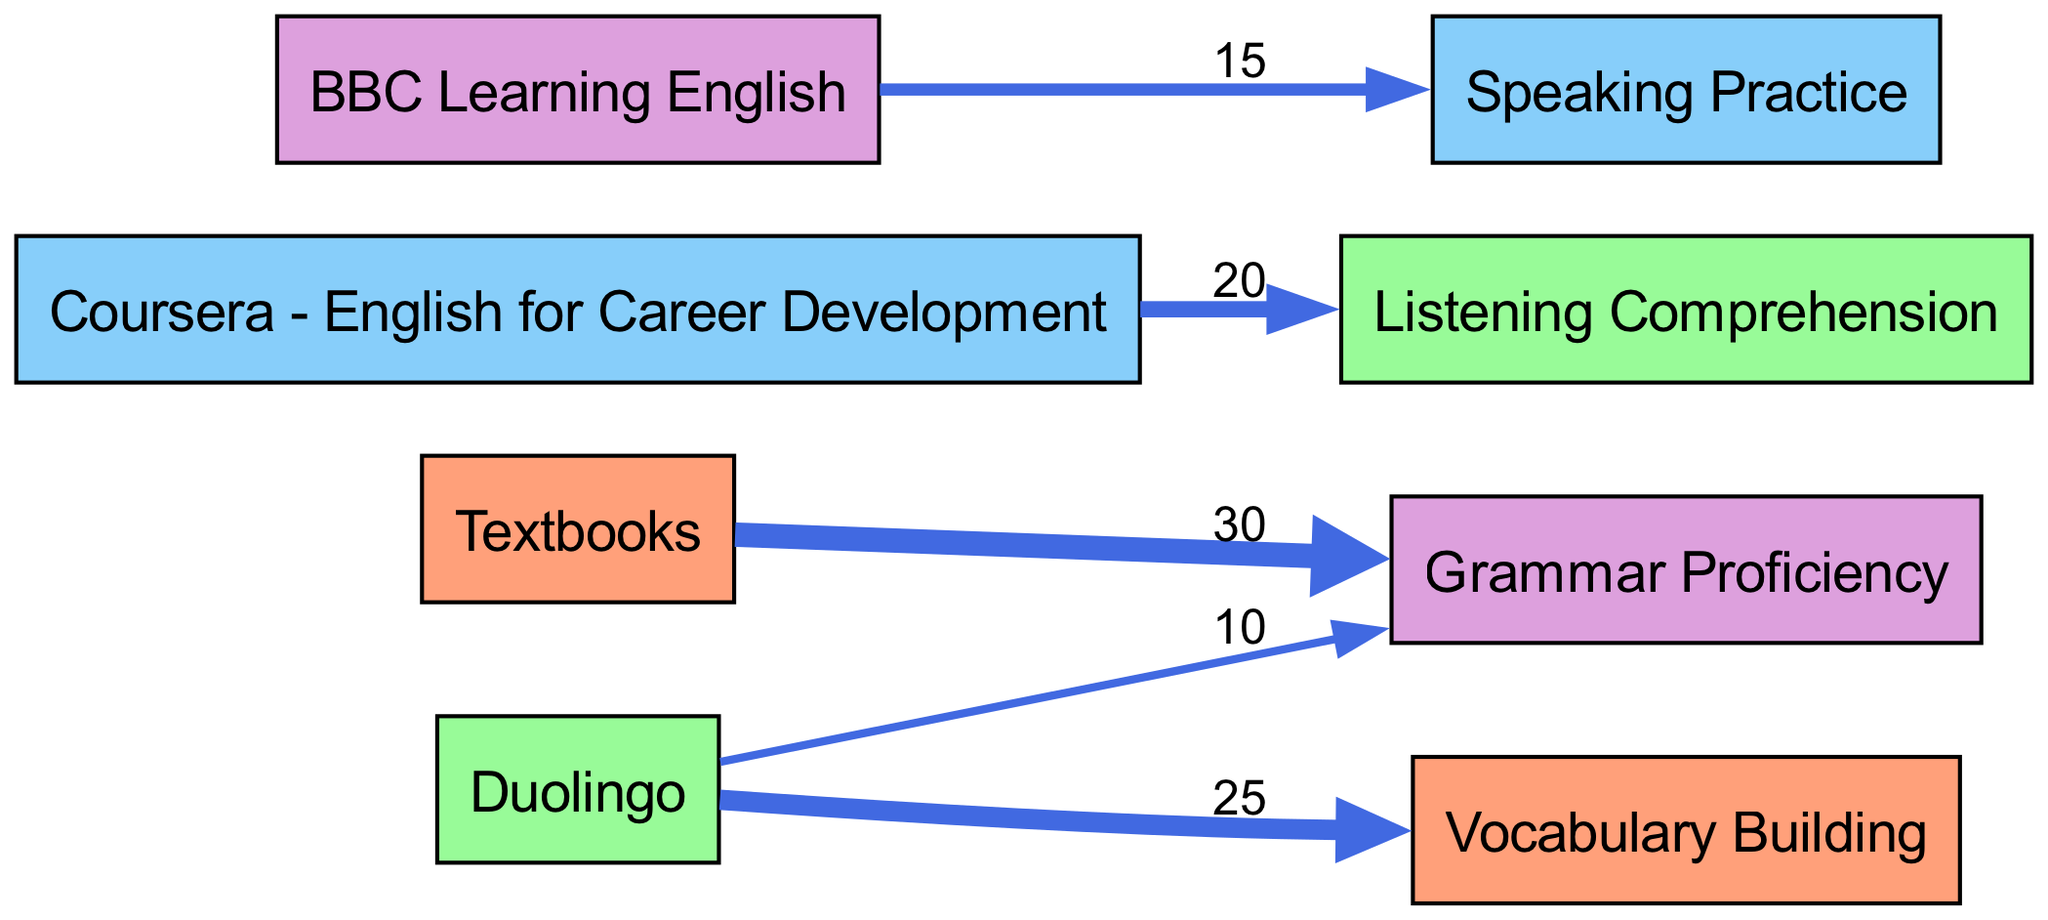What is the value indicating connection between Textbooks and Grammar Proficiency? The connection between Textbooks and Grammar Proficiency shows the value of 30, which is indicated directly on the edge connecting these two nodes in the diagram.
Answer: 30 Which learning resource has the highest connection value? By comparing the connection values of all resources, Textbooks has the highest connection value of 30 to Grammar Proficiency, making it the resource with the most significant impact.
Answer: Textbooks How many total distinct learning goals are represented in the diagram? There are four distinct learning goals represented: Vocabulary Building, Listening Comprehension, Speaking Practice, and Grammar Proficiency, each connected to different resources.
Answer: Four Which app is associated with Vocabulary Building? The app associated with Vocabulary Building is Duolingo, as indicated by the edge connecting Duolingo to Vocabulary Building with a value of 25.
Answer: Duolingo What is the total value of connections from Duolingo? To find the total, we add the connection values from Duolingo: 25 (Vocabulary Building) + 10 (Grammar Proficiency), resulting in a total of 35.
Answer: 35 Which learning goal has the least connection value? The learning goal with the least connection value is Speaking Practice, which has a value of 15 associated with BBC Learning English.
Answer: Speaking Practice How many edges are there in the diagram? By counting the connections shown, there are a total of five edges connecting the resources to their corresponding learning goals in the diagram.
Answer: Five What is the relationship between Coursera - English for Career Development and Listening Comprehension? The relationship is indicated by a direct edge from Coursera - English for Career Development to Listening Comprehension, with a connection value of 20.
Answer: 20 What percentage of total connections does Textbooks represent? Textbooks has a connection value of 30, and the total connection value is 100 (30 + 25 + 20 + 15 + 10). The percentage calculation gives (30/100) * 100%, which yields 30%.
Answer: 30% 